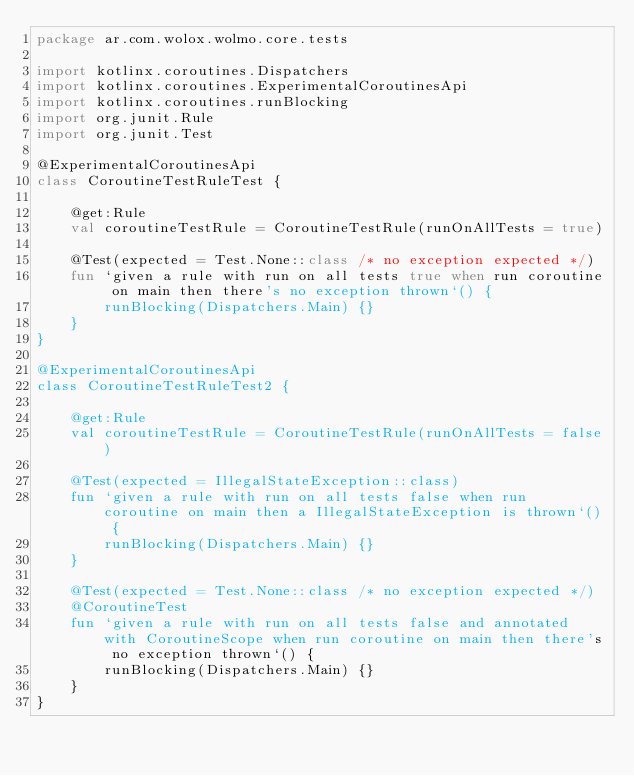Convert code to text. <code><loc_0><loc_0><loc_500><loc_500><_Kotlin_>package ar.com.wolox.wolmo.core.tests

import kotlinx.coroutines.Dispatchers
import kotlinx.coroutines.ExperimentalCoroutinesApi
import kotlinx.coroutines.runBlocking
import org.junit.Rule
import org.junit.Test

@ExperimentalCoroutinesApi
class CoroutineTestRuleTest {

    @get:Rule
    val coroutineTestRule = CoroutineTestRule(runOnAllTests = true)

    @Test(expected = Test.None::class /* no exception expected */)
    fun `given a rule with run on all tests true when run coroutine on main then there's no exception thrown`() {
        runBlocking(Dispatchers.Main) {}
    }
}

@ExperimentalCoroutinesApi
class CoroutineTestRuleTest2 {

    @get:Rule
    val coroutineTestRule = CoroutineTestRule(runOnAllTests = false)

    @Test(expected = IllegalStateException::class)
    fun `given a rule with run on all tests false when run coroutine on main then a IllegalStateException is thrown`() {
        runBlocking(Dispatchers.Main) {}
    }

    @Test(expected = Test.None::class /* no exception expected */)
    @CoroutineTest
    fun `given a rule with run on all tests false and annotated with CoroutineScope when run coroutine on main then there's no exception thrown`() {
        runBlocking(Dispatchers.Main) {}
    }
}</code> 